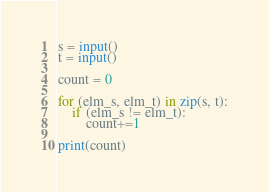Convert code to text. <code><loc_0><loc_0><loc_500><loc_500><_Python_>s = input()
t = input()

count = 0

for (elm_s, elm_t) in zip(s, t):
    if (elm_s != elm_t):
        count+=1

print(count)</code> 